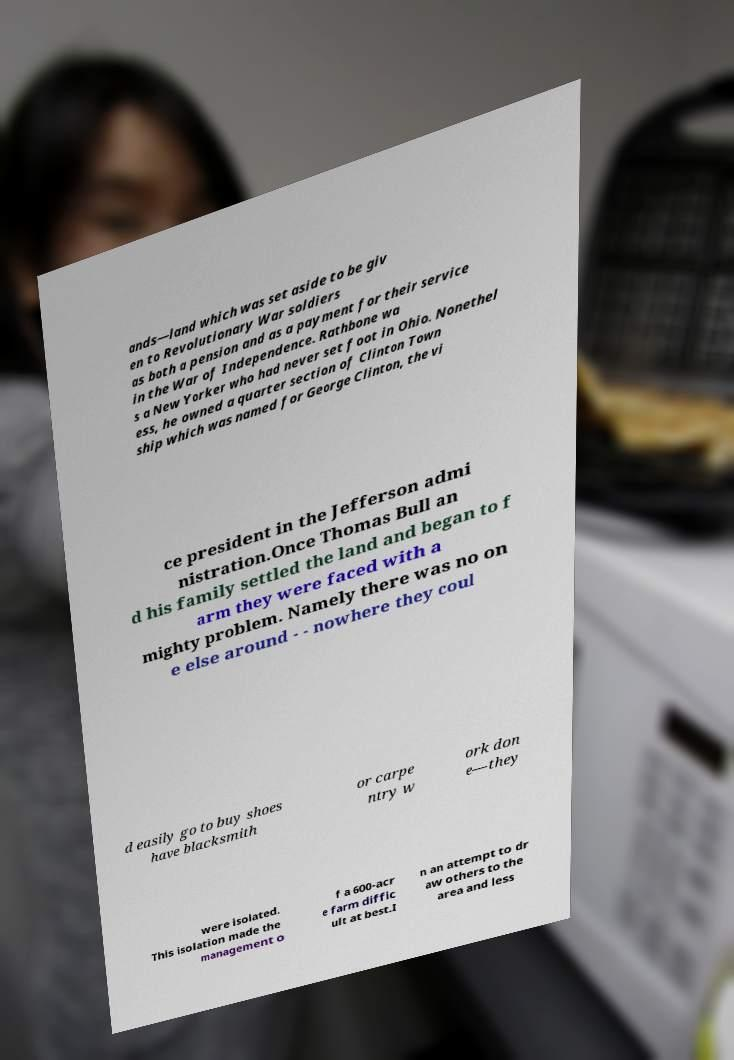Could you extract and type out the text from this image? ands—land which was set aside to be giv en to Revolutionary War soldiers as both a pension and as a payment for their service in the War of Independence. Rathbone wa s a New Yorker who had never set foot in Ohio. Nonethel ess, he owned a quarter section of Clinton Town ship which was named for George Clinton, the vi ce president in the Jefferson admi nistration.Once Thomas Bull an d his family settled the land and began to f arm they were faced with a mighty problem. Namely there was no on e else around - - nowhere they coul d easily go to buy shoes have blacksmith or carpe ntry w ork don e—they were isolated. This isolation made the management o f a 600-acr e farm diffic ult at best.I n an attempt to dr aw others to the area and less 